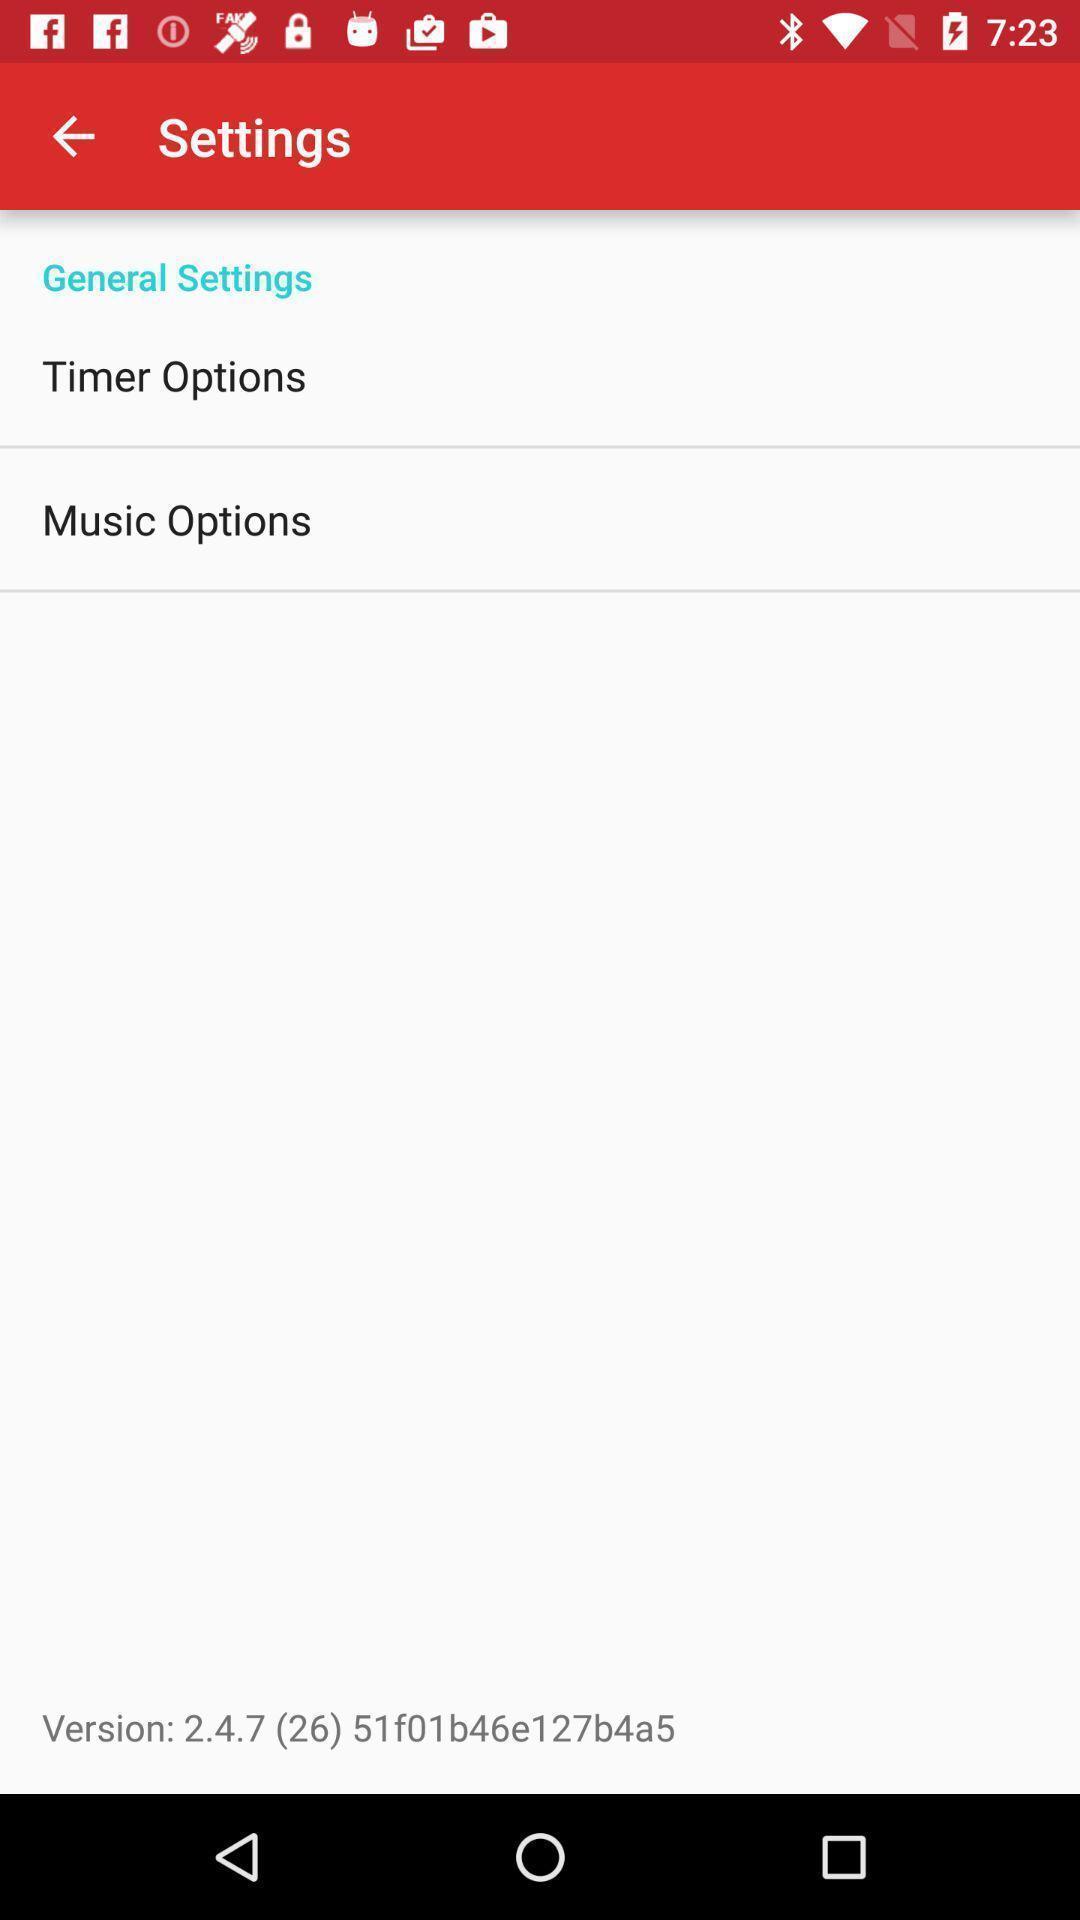Explain the elements present in this screenshot. Settings page. 